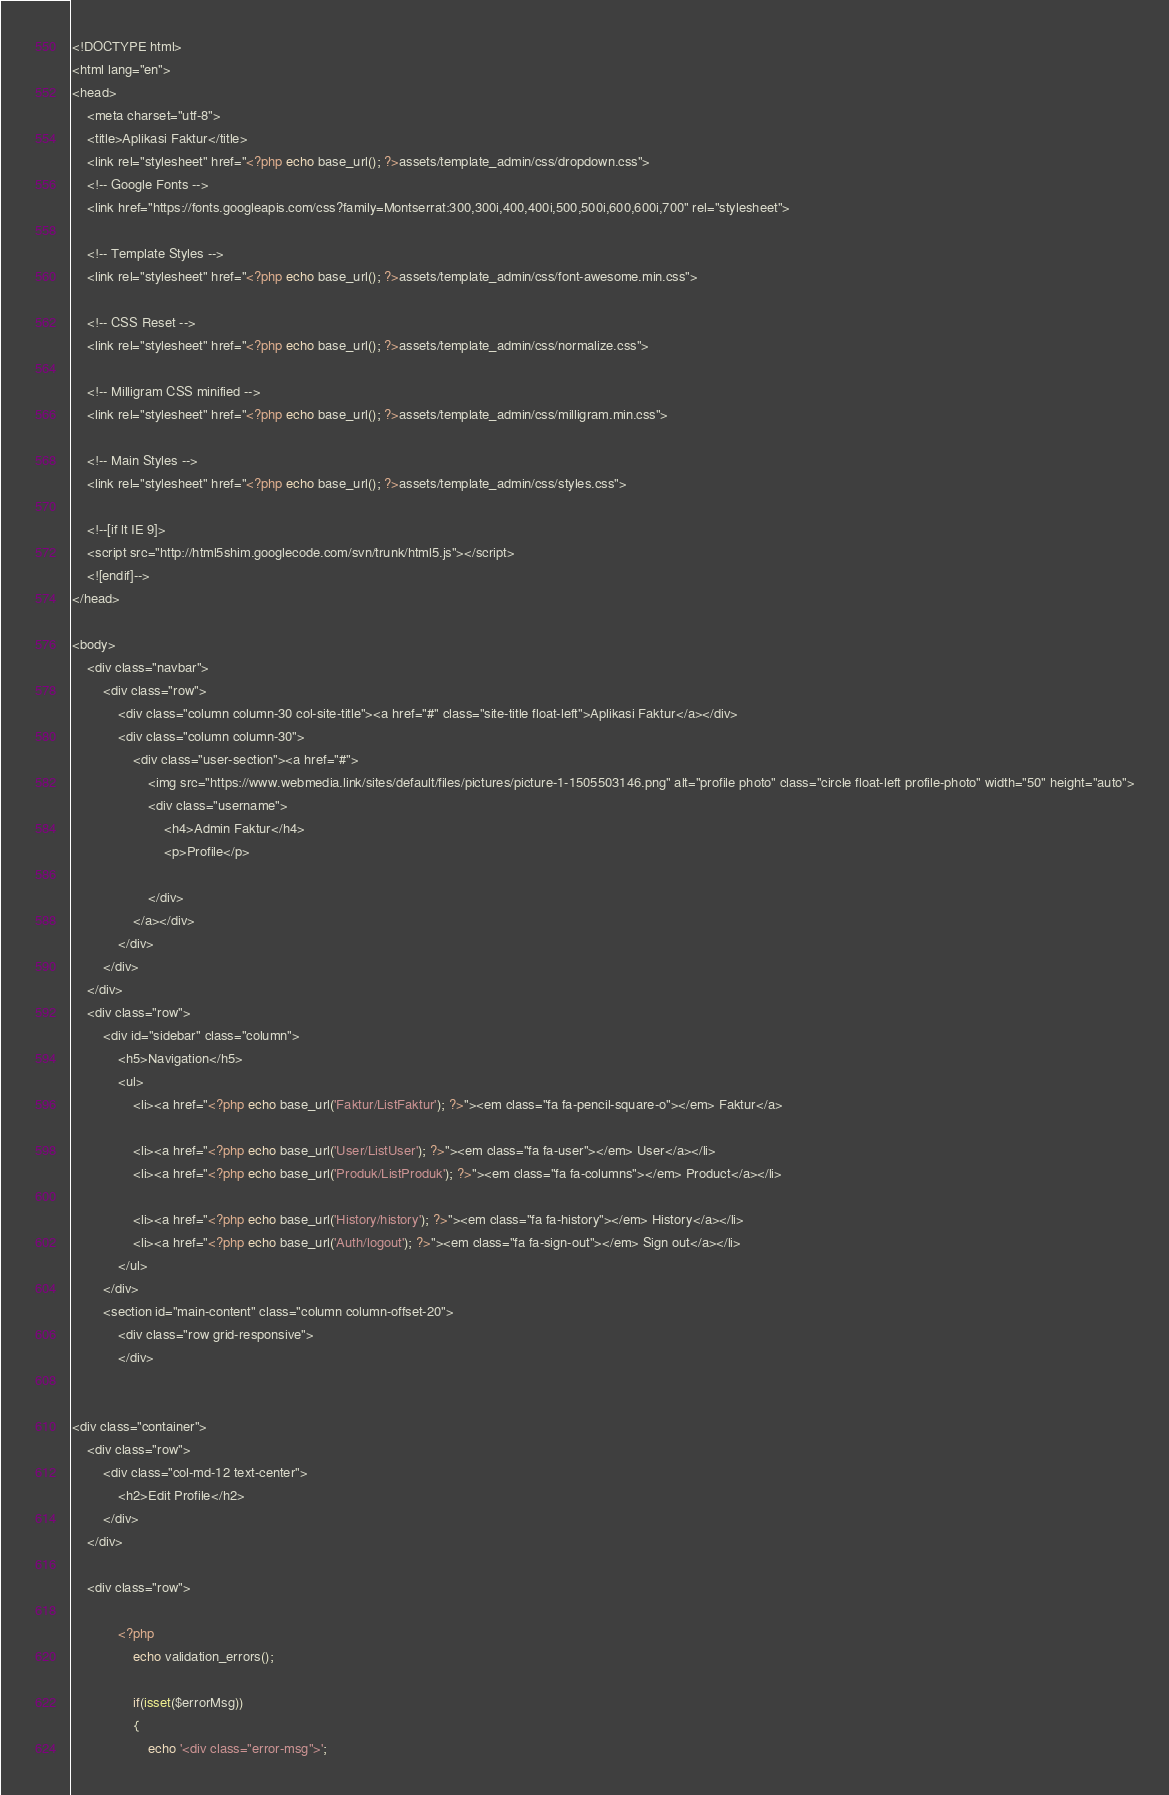Convert code to text. <code><loc_0><loc_0><loc_500><loc_500><_PHP_><!DOCTYPE html>
<html lang="en">
<head>
	<meta charset="utf-8">
	<title>Aplikasi Faktur</title>
	<link rel="stylesheet" href="<?php echo base_url(); ?>assets/template_admin/css/dropdown.css">
	<!-- Google Fonts -->
	<link href="https://fonts.googleapis.com/css?family=Montserrat:300,300i,400,400i,500,500i,600,600i,700" rel="stylesheet">
	
	<!-- Template Styles -->
	<link rel="stylesheet" href="<?php echo base_url(); ?>assets/template_admin/css/font-awesome.min.css">
	
	<!-- CSS Reset -->
	<link rel="stylesheet" href="<?php echo base_url(); ?>assets/template_admin/css/normalize.css">
	
	<!-- Milligram CSS minified -->
	<link rel="stylesheet" href="<?php echo base_url(); ?>assets/template_admin/css/milligram.min.css">
	
	<!-- Main Styles -->
	<link rel="stylesheet" href="<?php echo base_url(); ?>assets/template_admin/css/styles.css">
	
	<!--[if lt IE 9]>
	<script src="http://html5shim.googlecode.com/svn/trunk/html5.js"></script>
	<![endif]-->
</head>

<body>
	<div class="navbar">
		<div class="row">
			<div class="column column-30 col-site-title"><a href="#" class="site-title float-left">Aplikasi Faktur</a></div>
			<div class="column column-30">
				<div class="user-section"><a href="#">
					<img src="https://www.webmedia.link/sites/default/files/pictures/picture-1-1505503146.png" alt="profile photo" class="circle float-left profile-photo" width="50" height="auto">
					<div class="username">
						<h4>Admin Faktur</h4>
						<p>Profile</p>

					</div>
				</a></div>
			</div>
		</div>
	</div>
	<div class="row">
		<div id="sidebar" class="column">
			<h5>Navigation</h5>
			<ul>	
				<li><a href="<?php echo base_url('Faktur/ListFaktur'); ?>"><em class="fa fa-pencil-square-o"></em> Faktur</a>

				<li><a href="<?php echo base_url('User/ListUser'); ?>"><em class="fa fa-user"></em> User</a></li>				
				<li><a href="<?php echo base_url('Produk/ListProduk'); ?>"><em class="fa fa-columns"></em> Product</a></li>
				
				<li><a href="<?php echo base_url('History/history'); ?>"><em class="fa fa-history"></em> History</a></li>
				<li><a href="<?php echo base_url('Auth/logout'); ?>"><em class="fa fa-sign-out"></em> Sign out</a></li>
			</ul>
		</div>
		<section id="main-content" class="column column-offset-20">
			<div class="row grid-responsive">
			</div>

	
<div class="container">
	<div class="row">
		<div class="col-md-12 text-center">
			<h2>Edit Profile</h2>
		</div>
	</div>
	
	<div class="row">
		
			<?php 
				echo validation_errors(); 
				
				if(isset($errorMsg))
				{
					echo '<div class="error-msg">';</code> 